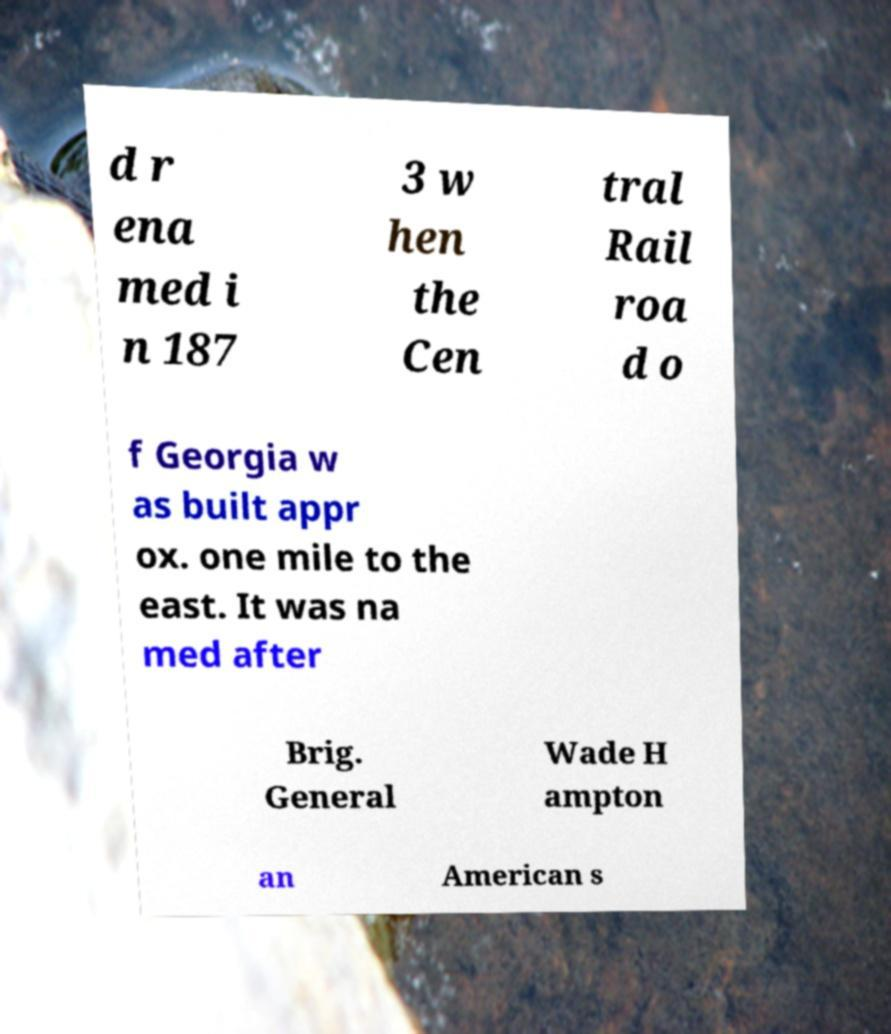What messages or text are displayed in this image? I need them in a readable, typed format. d r ena med i n 187 3 w hen the Cen tral Rail roa d o f Georgia w as built appr ox. one mile to the east. It was na med after Brig. General Wade H ampton an American s 